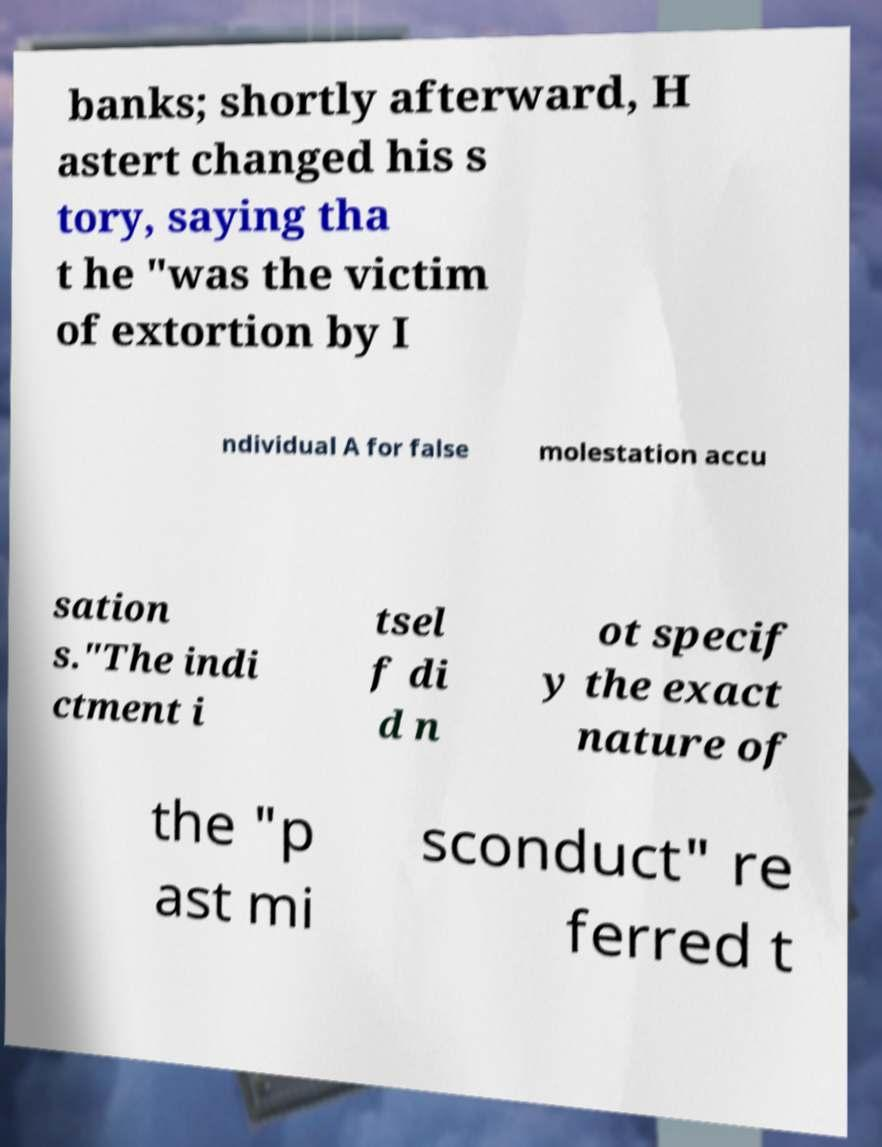For documentation purposes, I need the text within this image transcribed. Could you provide that? banks; shortly afterward, H astert changed his s tory, saying tha t he "was the victim of extortion by I ndividual A for false molestation accu sation s."The indi ctment i tsel f di d n ot specif y the exact nature of the "p ast mi sconduct" re ferred t 